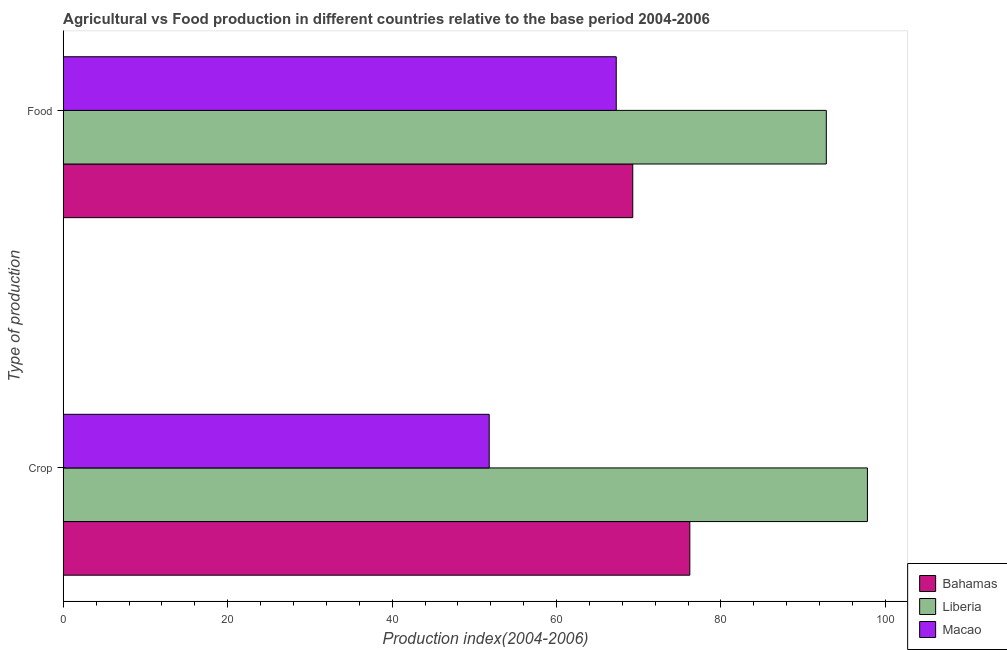How many different coloured bars are there?
Make the answer very short. 3. How many groups of bars are there?
Ensure brevity in your answer.  2. What is the label of the 2nd group of bars from the top?
Offer a very short reply. Crop. What is the food production index in Liberia?
Provide a short and direct response. 92.81. Across all countries, what is the maximum food production index?
Provide a short and direct response. 92.81. Across all countries, what is the minimum food production index?
Offer a very short reply. 67.26. In which country was the food production index maximum?
Ensure brevity in your answer.  Liberia. In which country was the crop production index minimum?
Offer a terse response. Macao. What is the total crop production index in the graph?
Offer a very short reply. 225.83. What is the difference between the food production index in Macao and that in Liberia?
Offer a terse response. -25.55. What is the average crop production index per country?
Your answer should be very brief. 75.28. What is the difference between the food production index and crop production index in Macao?
Provide a short and direct response. 15.45. What is the ratio of the crop production index in Liberia to that in Bahamas?
Ensure brevity in your answer.  1.28. Is the crop production index in Macao less than that in Liberia?
Make the answer very short. Yes. What does the 3rd bar from the top in Food represents?
Give a very brief answer. Bahamas. What does the 2nd bar from the bottom in Crop represents?
Offer a very short reply. Liberia. Are all the bars in the graph horizontal?
Provide a short and direct response. Yes. What is the difference between two consecutive major ticks on the X-axis?
Make the answer very short. 20. Does the graph contain any zero values?
Provide a short and direct response. No. Where does the legend appear in the graph?
Your answer should be compact. Bottom right. What is the title of the graph?
Your answer should be very brief. Agricultural vs Food production in different countries relative to the base period 2004-2006. Does "Cote d'Ivoire" appear as one of the legend labels in the graph?
Give a very brief answer. No. What is the label or title of the X-axis?
Offer a terse response. Production index(2004-2006). What is the label or title of the Y-axis?
Your answer should be very brief. Type of production. What is the Production index(2004-2006) in Bahamas in Crop?
Offer a terse response. 76.21. What is the Production index(2004-2006) of Liberia in Crop?
Offer a very short reply. 97.81. What is the Production index(2004-2006) of Macao in Crop?
Provide a short and direct response. 51.81. What is the Production index(2004-2006) in Bahamas in Food?
Provide a succinct answer. 69.27. What is the Production index(2004-2006) in Liberia in Food?
Your response must be concise. 92.81. What is the Production index(2004-2006) of Macao in Food?
Provide a short and direct response. 67.26. Across all Type of production, what is the maximum Production index(2004-2006) of Bahamas?
Provide a short and direct response. 76.21. Across all Type of production, what is the maximum Production index(2004-2006) of Liberia?
Your answer should be compact. 97.81. Across all Type of production, what is the maximum Production index(2004-2006) of Macao?
Make the answer very short. 67.26. Across all Type of production, what is the minimum Production index(2004-2006) in Bahamas?
Offer a very short reply. 69.27. Across all Type of production, what is the minimum Production index(2004-2006) of Liberia?
Ensure brevity in your answer.  92.81. Across all Type of production, what is the minimum Production index(2004-2006) of Macao?
Offer a terse response. 51.81. What is the total Production index(2004-2006) of Bahamas in the graph?
Offer a terse response. 145.48. What is the total Production index(2004-2006) in Liberia in the graph?
Your response must be concise. 190.62. What is the total Production index(2004-2006) in Macao in the graph?
Give a very brief answer. 119.07. What is the difference between the Production index(2004-2006) of Bahamas in Crop and that in Food?
Your response must be concise. 6.94. What is the difference between the Production index(2004-2006) of Macao in Crop and that in Food?
Offer a terse response. -15.45. What is the difference between the Production index(2004-2006) of Bahamas in Crop and the Production index(2004-2006) of Liberia in Food?
Offer a very short reply. -16.6. What is the difference between the Production index(2004-2006) of Bahamas in Crop and the Production index(2004-2006) of Macao in Food?
Provide a succinct answer. 8.95. What is the difference between the Production index(2004-2006) of Liberia in Crop and the Production index(2004-2006) of Macao in Food?
Provide a succinct answer. 30.55. What is the average Production index(2004-2006) in Bahamas per Type of production?
Provide a short and direct response. 72.74. What is the average Production index(2004-2006) in Liberia per Type of production?
Give a very brief answer. 95.31. What is the average Production index(2004-2006) of Macao per Type of production?
Your answer should be compact. 59.53. What is the difference between the Production index(2004-2006) of Bahamas and Production index(2004-2006) of Liberia in Crop?
Provide a short and direct response. -21.6. What is the difference between the Production index(2004-2006) in Bahamas and Production index(2004-2006) in Macao in Crop?
Make the answer very short. 24.4. What is the difference between the Production index(2004-2006) of Liberia and Production index(2004-2006) of Macao in Crop?
Your answer should be compact. 46. What is the difference between the Production index(2004-2006) in Bahamas and Production index(2004-2006) in Liberia in Food?
Your response must be concise. -23.54. What is the difference between the Production index(2004-2006) in Bahamas and Production index(2004-2006) in Macao in Food?
Provide a short and direct response. 2.01. What is the difference between the Production index(2004-2006) of Liberia and Production index(2004-2006) of Macao in Food?
Your answer should be very brief. 25.55. What is the ratio of the Production index(2004-2006) in Bahamas in Crop to that in Food?
Offer a very short reply. 1.1. What is the ratio of the Production index(2004-2006) of Liberia in Crop to that in Food?
Offer a terse response. 1.05. What is the ratio of the Production index(2004-2006) in Macao in Crop to that in Food?
Give a very brief answer. 0.77. What is the difference between the highest and the second highest Production index(2004-2006) in Bahamas?
Offer a very short reply. 6.94. What is the difference between the highest and the second highest Production index(2004-2006) in Liberia?
Ensure brevity in your answer.  5. What is the difference between the highest and the second highest Production index(2004-2006) in Macao?
Your response must be concise. 15.45. What is the difference between the highest and the lowest Production index(2004-2006) in Bahamas?
Ensure brevity in your answer.  6.94. What is the difference between the highest and the lowest Production index(2004-2006) of Macao?
Your response must be concise. 15.45. 